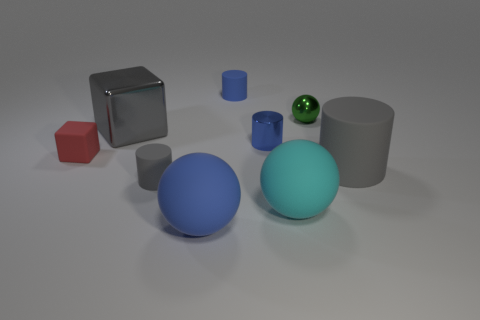How many large gray rubber cylinders are behind the tiny sphere?
Make the answer very short. 0. There is a thing that is on the right side of the red object and left of the small gray rubber cylinder; what is it made of?
Offer a terse response. Metal. How many spheres are big gray metallic things or large cyan objects?
Give a very brief answer. 1. There is a tiny gray object that is the same shape as the blue shiny object; what material is it?
Offer a terse response. Rubber. What is the size of the cube that is made of the same material as the large cyan thing?
Your response must be concise. Small. Do the large gray thing that is on the right side of the big cyan sphere and the gray matte thing left of the big blue object have the same shape?
Give a very brief answer. Yes. What is the color of the sphere that is made of the same material as the large gray block?
Your response must be concise. Green. Does the blue rubber thing behind the green sphere have the same size as the matte cylinder on the right side of the green metallic thing?
Offer a terse response. No. There is a thing that is both in front of the green ball and on the right side of the big cyan rubber thing; what is its shape?
Your response must be concise. Cylinder. Are there any tiny gray cylinders that have the same material as the green thing?
Offer a very short reply. No. 